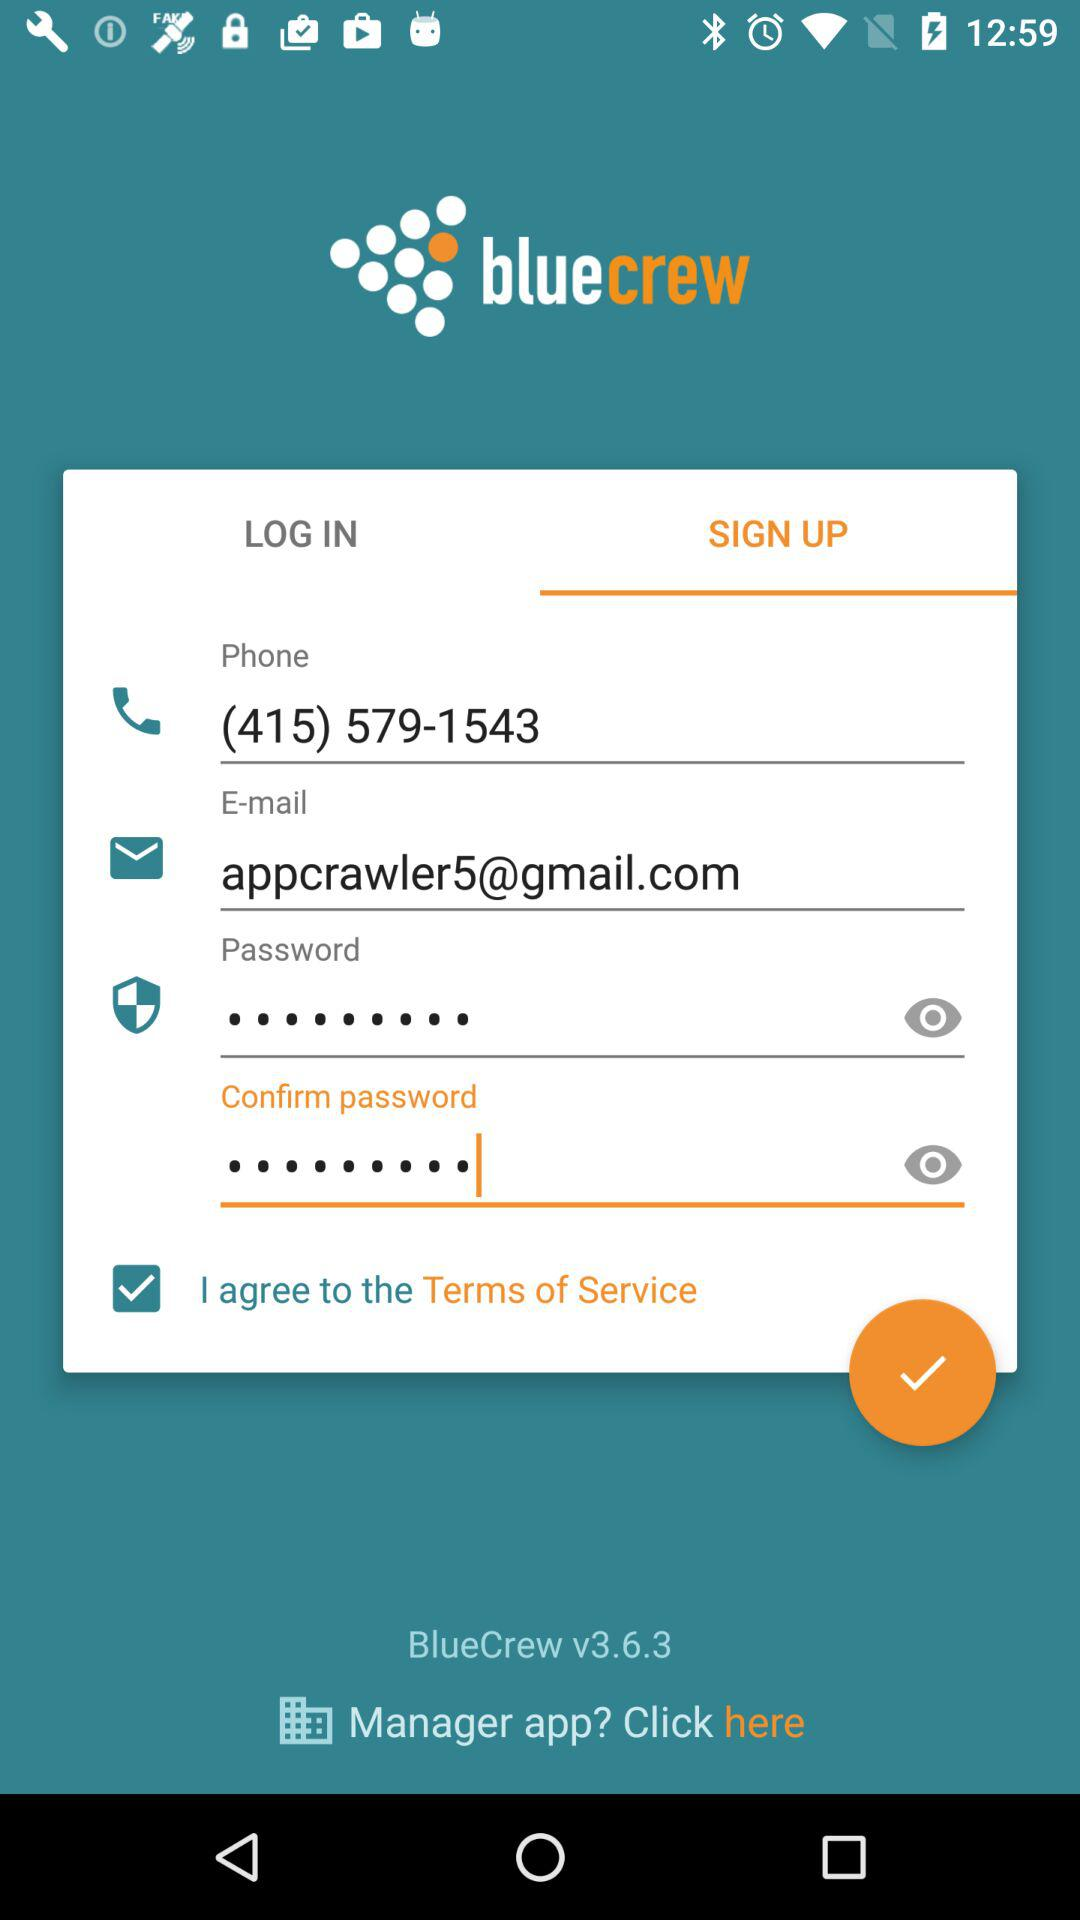Which tab has been selected? The selected tab is "SIGN UP". 